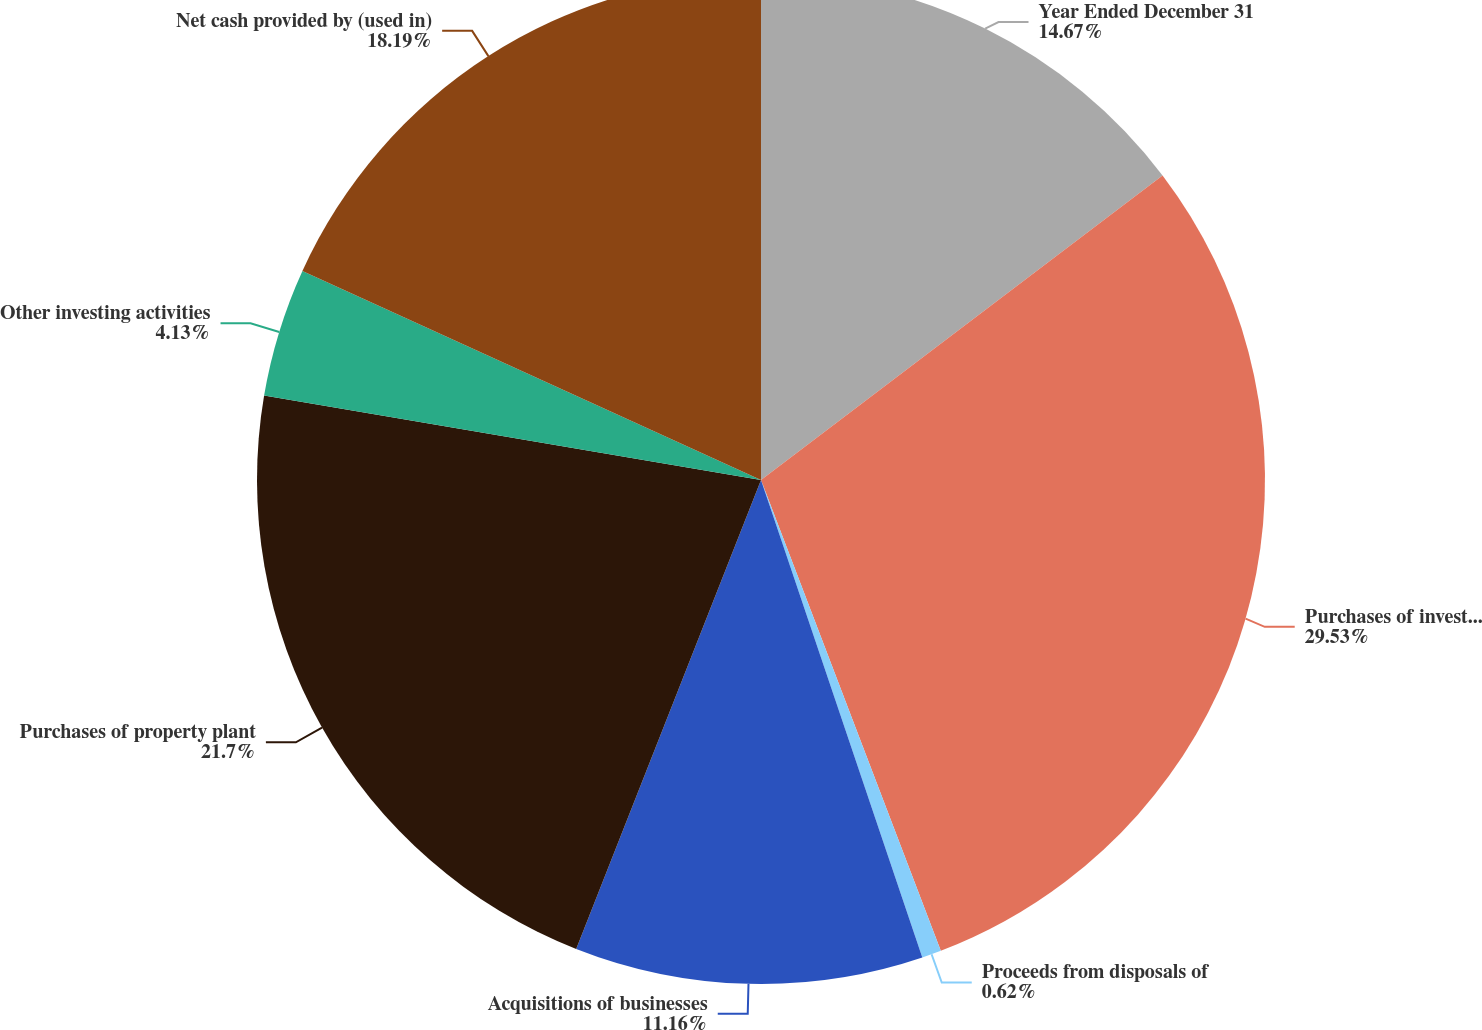Convert chart to OTSL. <chart><loc_0><loc_0><loc_500><loc_500><pie_chart><fcel>Year Ended December 31<fcel>Purchases of investments<fcel>Proceeds from disposals of<fcel>Acquisitions of businesses<fcel>Purchases of property plant<fcel>Other investing activities<fcel>Net cash provided by (used in)<nl><fcel>14.67%<fcel>29.52%<fcel>0.62%<fcel>11.16%<fcel>21.7%<fcel>4.13%<fcel>18.19%<nl></chart> 